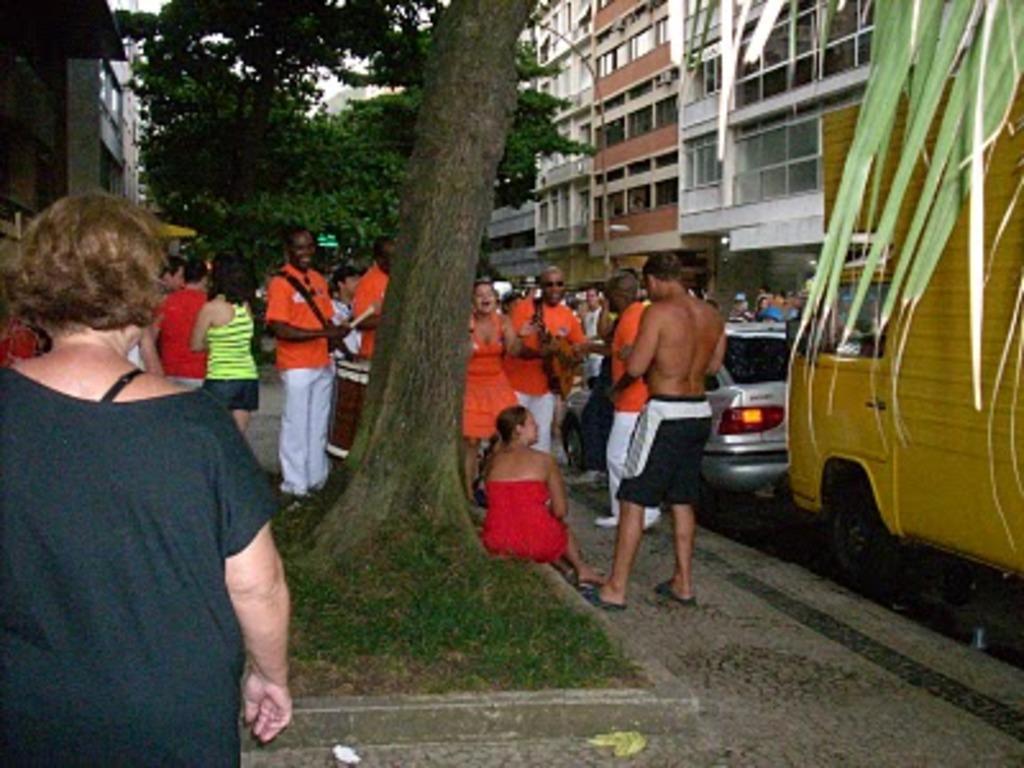Could you give a brief overview of what you see in this image? In the foreground of the image we can see a woman and a tree. The woman is wearing black color dress. Behind the tree, we can see so many people are standing and one woman is sitting on the pavement. She is wearing a red color dress. We can see vehicles and buildings on the right side of the image. In the background of the image, there are trees and buildings. 